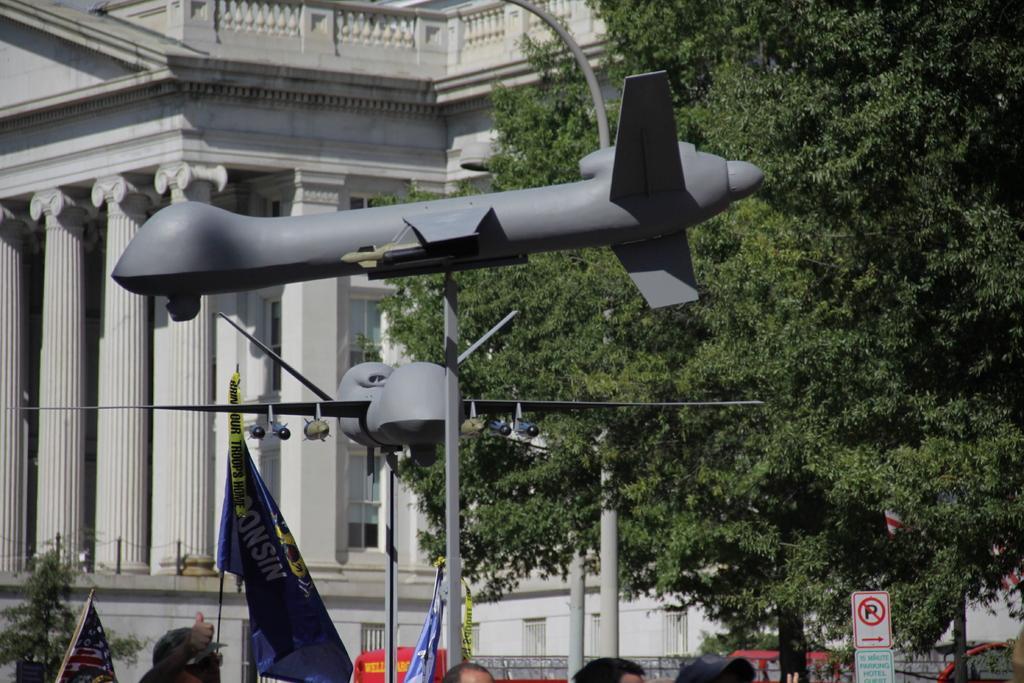Please provide a concise description of this image. In this image we can see building, windows, plants, trees, there are flags, poles, aircraft toys, also we can see heads of people, and there are sign boards. 